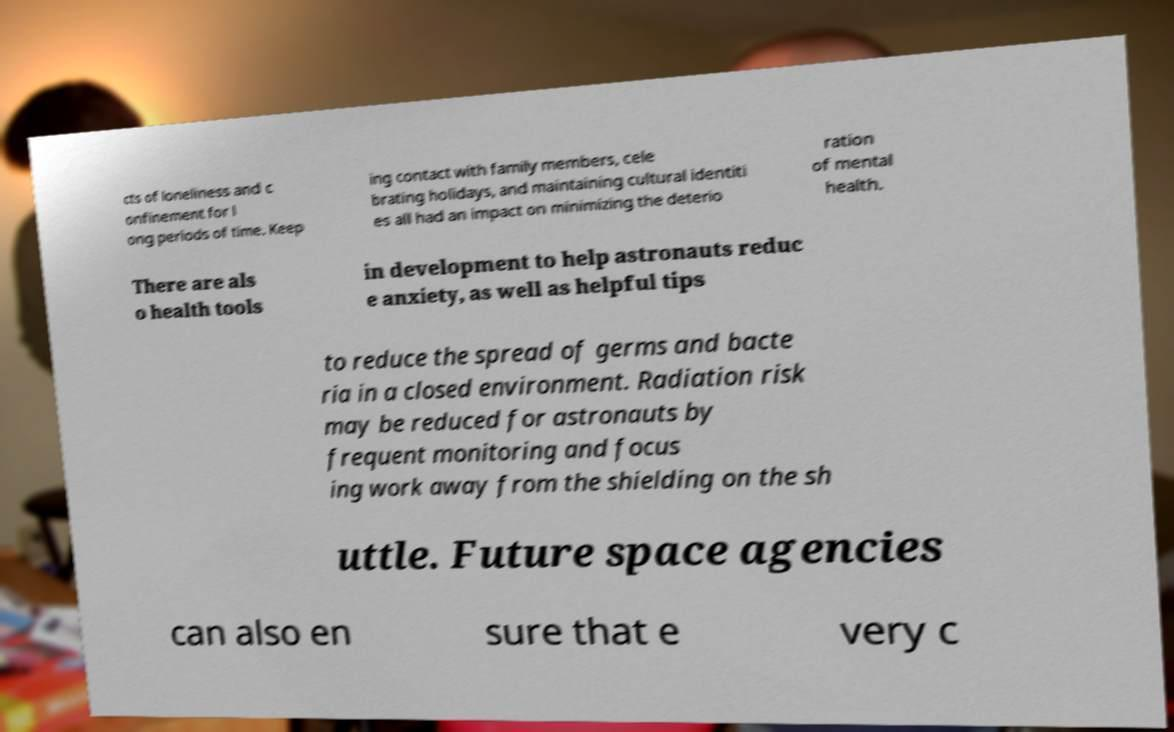There's text embedded in this image that I need extracted. Can you transcribe it verbatim? cts of loneliness and c onfinement for l ong periods of time. Keep ing contact with family members, cele brating holidays, and maintaining cultural identiti es all had an impact on minimizing the deterio ration of mental health. There are als o health tools in development to help astronauts reduc e anxiety, as well as helpful tips to reduce the spread of germs and bacte ria in a closed environment. Radiation risk may be reduced for astronauts by frequent monitoring and focus ing work away from the shielding on the sh uttle. Future space agencies can also en sure that e very c 